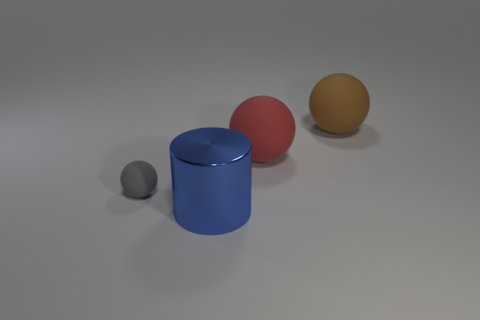What is the sphere that is to the left of the blue shiny thing made of?
Your response must be concise. Rubber. Are there an equal number of blue metal things on the right side of the blue metallic cylinder and small green cubes?
Offer a very short reply. Yes. There is another big thing that is the same shape as the large red thing; what color is it?
Provide a succinct answer. Brown. Do the gray matte object and the blue shiny cylinder have the same size?
Give a very brief answer. No. Is the number of blue objects that are on the right side of the brown rubber thing the same as the number of large brown rubber things that are left of the gray matte object?
Provide a succinct answer. Yes. Are any gray shiny cylinders visible?
Make the answer very short. No. What size is the gray matte thing that is the same shape as the brown object?
Provide a short and direct response. Small. There is a thing on the left side of the big blue cylinder; what is its size?
Make the answer very short. Small. Is the number of rubber things that are left of the blue shiny object greater than the number of red matte balls?
Provide a short and direct response. No. There is a brown thing; what shape is it?
Offer a very short reply. Sphere. 